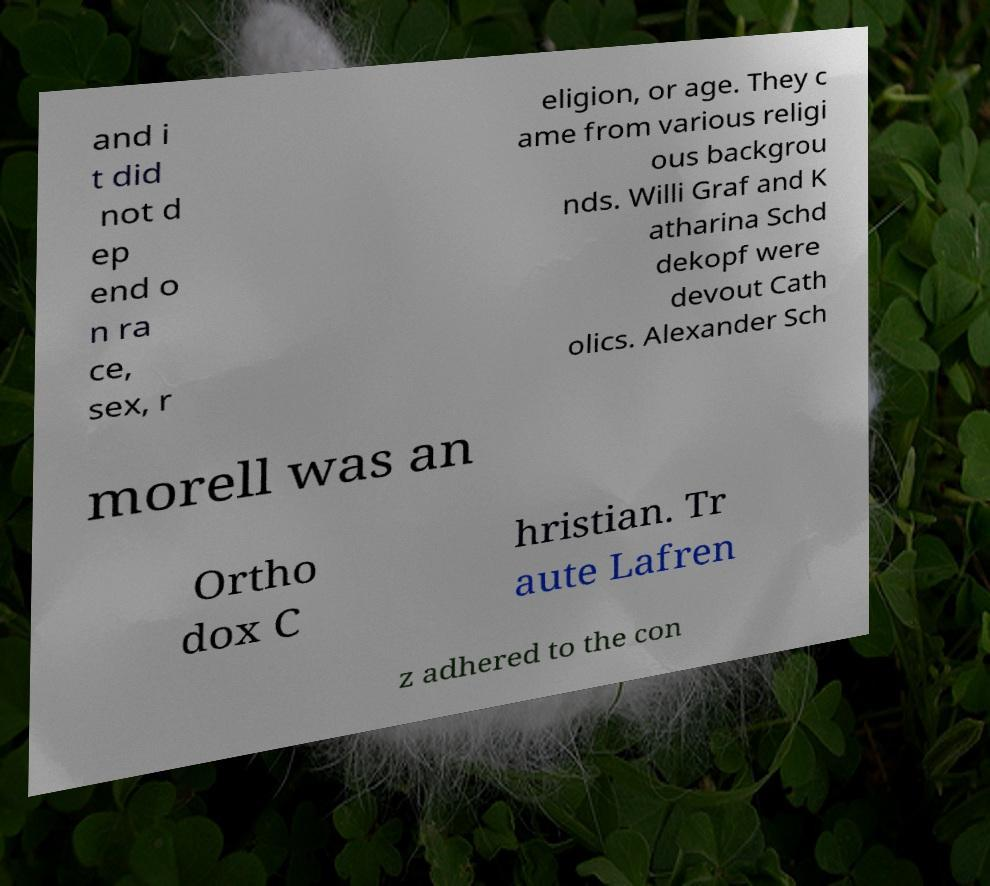Please read and relay the text visible in this image. What does it say? and i t did not d ep end o n ra ce, sex, r eligion, or age. They c ame from various religi ous backgrou nds. Willi Graf and K atharina Schd dekopf were devout Cath olics. Alexander Sch morell was an Ortho dox C hristian. Tr aute Lafren z adhered to the con 